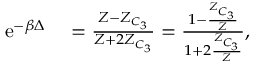Convert formula to latex. <formula><loc_0><loc_0><loc_500><loc_500>\begin{array} { r l } { e ^ { - \beta \Delta } } & = \frac { Z - Z _ { C _ { 3 } } } { Z + 2 Z _ { C _ { 3 } } } = \frac { 1 - \frac { Z _ { C _ { 3 } } } { Z } } { 1 + 2 \frac { Z _ { C _ { 3 } } } { Z } } , } \end{array}</formula> 